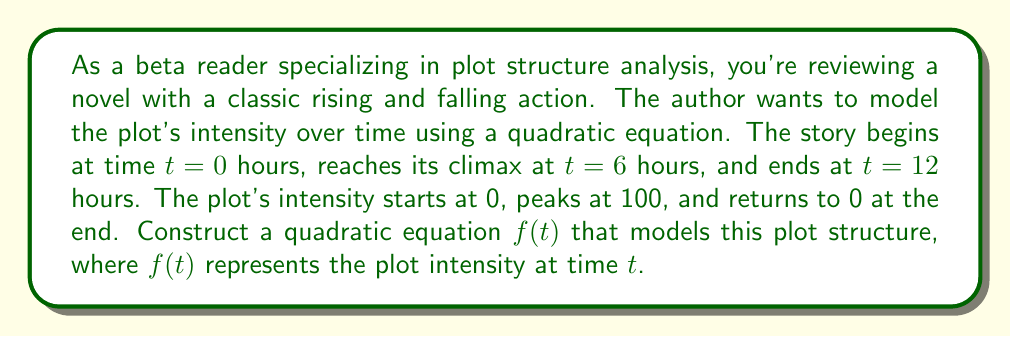Give your solution to this math problem. To model this plot structure with a quadratic equation, we'll use the general form:

$$f(t) = a(t-h)^2 + k$$

Where $(h,k)$ is the vertex of the parabola, representing the climax of the story.

Given information:
- Story begins at $t=0$ with intensity 0
- Climax occurs at $t=6$ with intensity 100
- Story ends at $t=12$ with intensity 0

Steps:
1. Identify the vertex: $(h,k) = (6,100)$

2. Substitute the vertex into the general form:
   $$f(t) = a(t-6)^2 + 100$$

3. Use the point $(0,0)$ to solve for $a$:
   $0 = a(0-6)^2 + 100$
   $0 = 36a + 100$
   $-100 = 36a$
   $a = -\frac{25}{9}$

4. The quadratic equation is:
   $$f(t) = -\frac{25}{9}(t-6)^2 + 100$$

5. Verify the end point $(12,0)$:
   $f(12) = -\frac{25}{9}(12-6)^2 + 100 = -\frac{25}{9}(6)^2 + 100 = -100 + 100 = 0$

This equation satisfies all given conditions and accurately models the plot structure.
Answer: $$f(t) = -\frac{25}{9}(t-6)^2 + 100$$ 